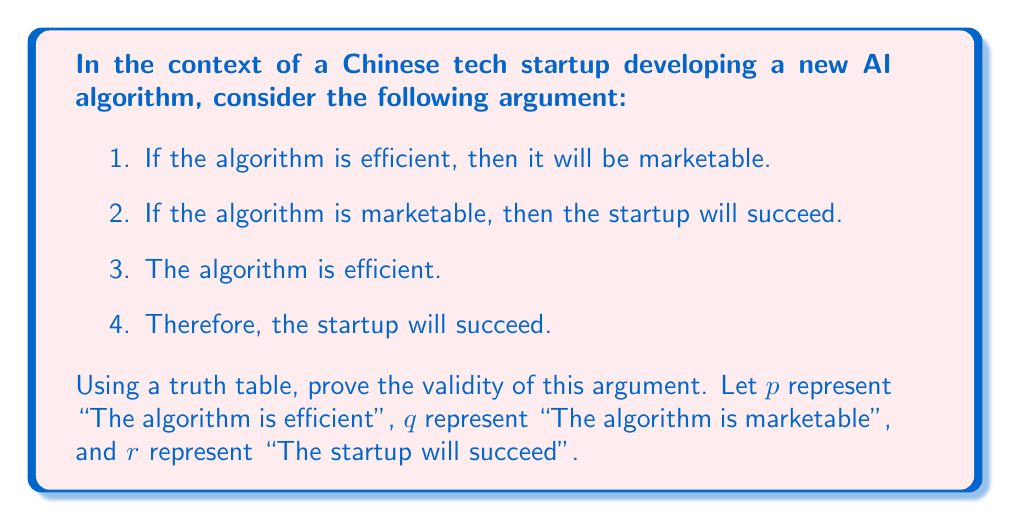Solve this math problem. To prove the validity of this argument using a truth table, we need to show that whenever all the premises are true, the conclusion is also true. Let's break this down step-by-step:

1. First, we need to identify the logical structure of the argument:
   Premise 1: $p \rightarrow q$
   Premise 2: $q \rightarrow r$
   Premise 3: $p$
   Conclusion: $r$

2. Now, let's construct a truth table with columns for $p$, $q$, $r$, and each premise:

   $$
   \begin{array}{cccc|ccc|c}
   p & q & r & p \rightarrow q & q \rightarrow r & p & (p \rightarrow q) \land (q \rightarrow r) \land p & r \\
   \hline
   T & T & T & T & T & T & T & T \\
   T & T & F & T & F & T & F & F \\
   T & F & T & F & T & T & F & T \\
   T & F & F & F & T & T & F & F \\
   F & T & T & T & T & F & F & T \\
   F & T & F & T & F & F & F & F \\
   F & F & T & T & T & F & F & T \\
   F & F & F & T & T & F & F & F \\
   \end{array}
   $$

3. The column $(p \rightarrow q) \land (q \rightarrow r) \land p$ represents all premises being true simultaneously.

4. For the argument to be valid, in every row where all premises are true (i.e., the column from step 3 is T), the conclusion $r$ must also be true.

5. We can see that there is only one row where all premises are true (the first row), and in this row, the conclusion $r$ is also true.

Therefore, the argument is valid because whenever all premises are true, the conclusion is also true.
Answer: The argument is valid. The truth table shows that when all premises $(p \rightarrow q) \land (q \rightarrow r) \land p$ are true, the conclusion $r$ is also true, which occurs in the first row of the truth table. 